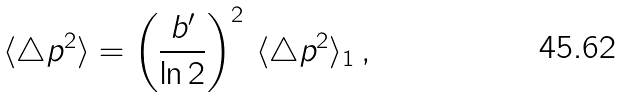<formula> <loc_0><loc_0><loc_500><loc_500>\langle \triangle p ^ { 2 } \rangle = \left ( \frac { b ^ { \prime } } { \ln 2 } \right ) ^ { 2 } \, \langle \triangle p ^ { 2 } \rangle _ { 1 } \, ,</formula> 